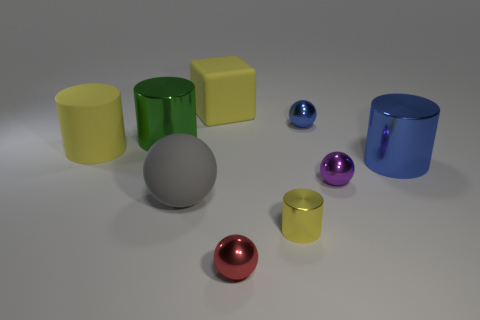Subtract 1 spheres. How many spheres are left? 3 Subtract all brown cylinders. Subtract all red cubes. How many cylinders are left? 4 Add 1 purple balls. How many objects exist? 10 Subtract all spheres. How many objects are left? 5 Add 7 yellow metal objects. How many yellow metal objects exist? 8 Subtract 1 blue cylinders. How many objects are left? 8 Subtract all large yellow cubes. Subtract all blue metallic things. How many objects are left? 6 Add 9 small yellow objects. How many small yellow objects are left? 10 